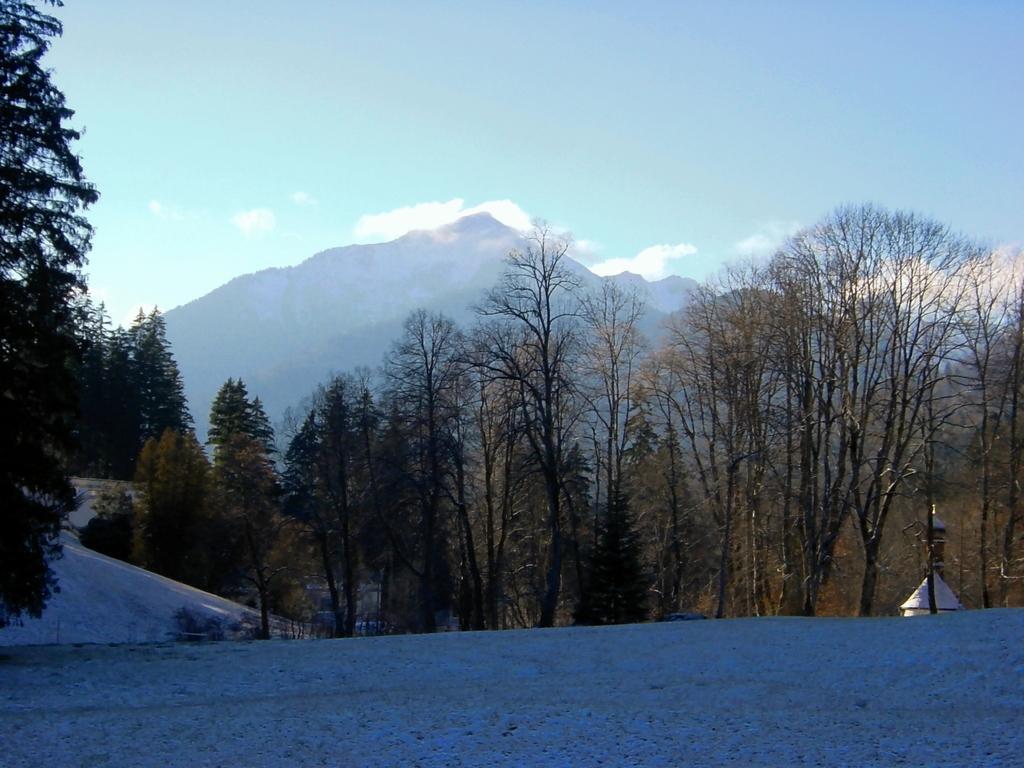Could you give a brief overview of what you see in this image? In the image there is an empty land in the foreground, behind that there are trees and mountains. 